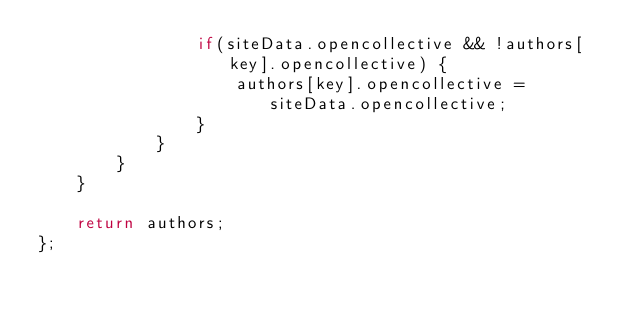<code> <loc_0><loc_0><loc_500><loc_500><_JavaScript_>				if(siteData.opencollective && !authors[key].opencollective) {
					authors[key].opencollective = siteData.opencollective;
				}
			}
		}
	}

	return authors;
};
</code> 